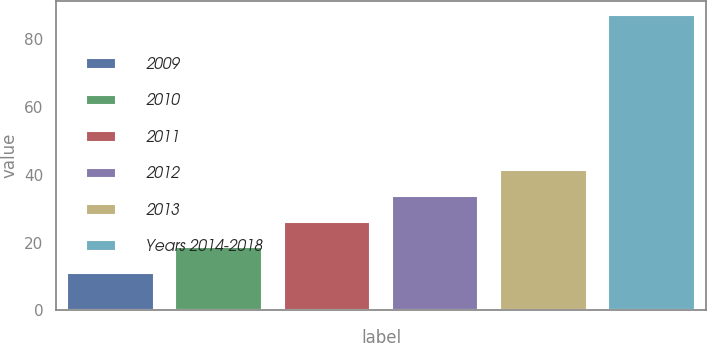<chart> <loc_0><loc_0><loc_500><loc_500><bar_chart><fcel>2009<fcel>2010<fcel>2011<fcel>2012<fcel>2013<fcel>Years 2014-2018<nl><fcel>11<fcel>18.6<fcel>26.2<fcel>33.8<fcel>41.4<fcel>87<nl></chart> 